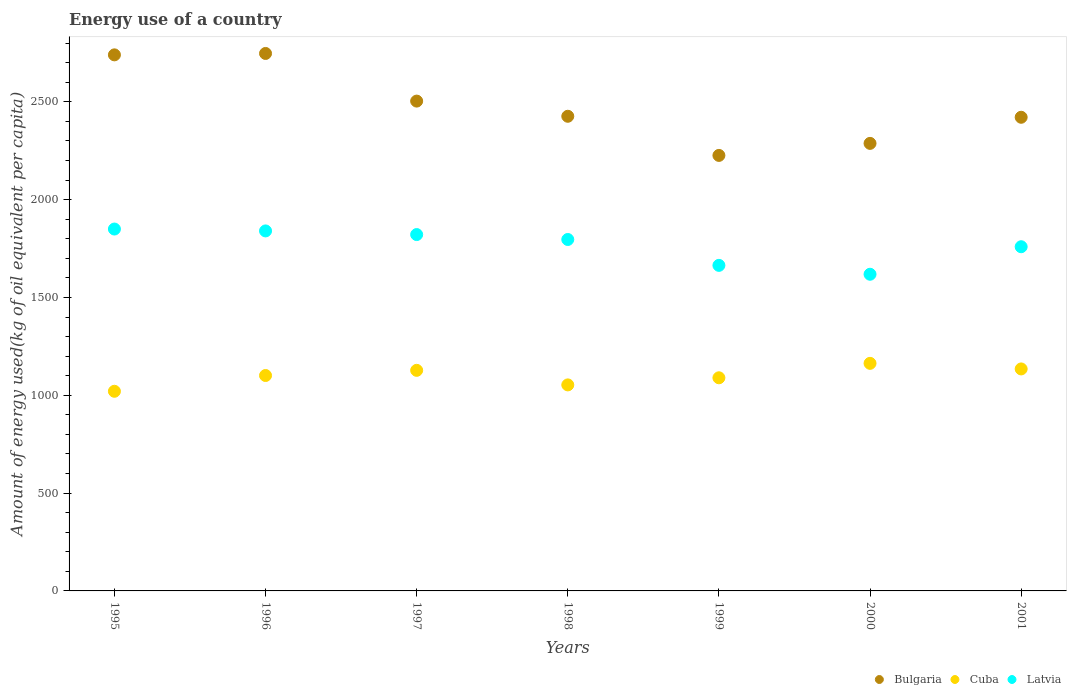How many different coloured dotlines are there?
Provide a succinct answer. 3. What is the amount of energy used in in Bulgaria in 1999?
Offer a terse response. 2225.87. Across all years, what is the maximum amount of energy used in in Latvia?
Provide a succinct answer. 1849.59. Across all years, what is the minimum amount of energy used in in Cuba?
Your answer should be very brief. 1020.37. In which year was the amount of energy used in in Latvia maximum?
Your answer should be very brief. 1995. What is the total amount of energy used in in Latvia in the graph?
Your answer should be very brief. 1.23e+04. What is the difference between the amount of energy used in in Bulgaria in 1999 and that in 2000?
Your answer should be very brief. -61.51. What is the difference between the amount of energy used in in Bulgaria in 1998 and the amount of energy used in in Latvia in 1997?
Your answer should be compact. 604.59. What is the average amount of energy used in in Cuba per year?
Offer a very short reply. 1098.4. In the year 1999, what is the difference between the amount of energy used in in Latvia and amount of energy used in in Bulgaria?
Your answer should be compact. -561.96. In how many years, is the amount of energy used in in Cuba greater than 2000 kg?
Make the answer very short. 0. What is the ratio of the amount of energy used in in Bulgaria in 1996 to that in 2000?
Your response must be concise. 1.2. Is the difference between the amount of energy used in in Latvia in 1997 and 1999 greater than the difference between the amount of energy used in in Bulgaria in 1997 and 1999?
Provide a short and direct response. No. What is the difference between the highest and the second highest amount of energy used in in Bulgaria?
Make the answer very short. 7.12. What is the difference between the highest and the lowest amount of energy used in in Latvia?
Your answer should be very brief. 231.13. Is the sum of the amount of energy used in in Bulgaria in 1998 and 2000 greater than the maximum amount of energy used in in Cuba across all years?
Your answer should be very brief. Yes. Is it the case that in every year, the sum of the amount of energy used in in Bulgaria and amount of energy used in in Latvia  is greater than the amount of energy used in in Cuba?
Make the answer very short. Yes. Is the amount of energy used in in Cuba strictly greater than the amount of energy used in in Latvia over the years?
Offer a terse response. No. Is the amount of energy used in in Bulgaria strictly less than the amount of energy used in in Latvia over the years?
Provide a short and direct response. No. How many years are there in the graph?
Your response must be concise. 7. How many legend labels are there?
Give a very brief answer. 3. What is the title of the graph?
Offer a terse response. Energy use of a country. What is the label or title of the Y-axis?
Your response must be concise. Amount of energy used(kg of oil equivalent per capita). What is the Amount of energy used(kg of oil equivalent per capita) of Bulgaria in 1995?
Keep it short and to the point. 2739.84. What is the Amount of energy used(kg of oil equivalent per capita) in Cuba in 1995?
Provide a succinct answer. 1020.37. What is the Amount of energy used(kg of oil equivalent per capita) in Latvia in 1995?
Provide a succinct answer. 1849.59. What is the Amount of energy used(kg of oil equivalent per capita) in Bulgaria in 1996?
Provide a succinct answer. 2746.96. What is the Amount of energy used(kg of oil equivalent per capita) of Cuba in 1996?
Ensure brevity in your answer.  1100.99. What is the Amount of energy used(kg of oil equivalent per capita) of Latvia in 1996?
Your response must be concise. 1839.98. What is the Amount of energy used(kg of oil equivalent per capita) in Bulgaria in 1997?
Provide a succinct answer. 2503.53. What is the Amount of energy used(kg of oil equivalent per capita) of Cuba in 1997?
Provide a short and direct response. 1127.4. What is the Amount of energy used(kg of oil equivalent per capita) of Latvia in 1997?
Keep it short and to the point. 1821.35. What is the Amount of energy used(kg of oil equivalent per capita) in Bulgaria in 1998?
Offer a very short reply. 2425.95. What is the Amount of energy used(kg of oil equivalent per capita) of Cuba in 1998?
Your answer should be very brief. 1053.01. What is the Amount of energy used(kg of oil equivalent per capita) in Latvia in 1998?
Your answer should be compact. 1796.18. What is the Amount of energy used(kg of oil equivalent per capita) of Bulgaria in 1999?
Your response must be concise. 2225.87. What is the Amount of energy used(kg of oil equivalent per capita) in Cuba in 1999?
Keep it short and to the point. 1089.34. What is the Amount of energy used(kg of oil equivalent per capita) in Latvia in 1999?
Give a very brief answer. 1663.92. What is the Amount of energy used(kg of oil equivalent per capita) of Bulgaria in 2000?
Ensure brevity in your answer.  2287.38. What is the Amount of energy used(kg of oil equivalent per capita) in Cuba in 2000?
Give a very brief answer. 1163.13. What is the Amount of energy used(kg of oil equivalent per capita) in Latvia in 2000?
Keep it short and to the point. 1618.46. What is the Amount of energy used(kg of oil equivalent per capita) of Bulgaria in 2001?
Make the answer very short. 2420.85. What is the Amount of energy used(kg of oil equivalent per capita) of Cuba in 2001?
Give a very brief answer. 1134.58. What is the Amount of energy used(kg of oil equivalent per capita) in Latvia in 2001?
Offer a very short reply. 1759.16. Across all years, what is the maximum Amount of energy used(kg of oil equivalent per capita) in Bulgaria?
Your answer should be very brief. 2746.96. Across all years, what is the maximum Amount of energy used(kg of oil equivalent per capita) in Cuba?
Provide a short and direct response. 1163.13. Across all years, what is the maximum Amount of energy used(kg of oil equivalent per capita) of Latvia?
Keep it short and to the point. 1849.59. Across all years, what is the minimum Amount of energy used(kg of oil equivalent per capita) of Bulgaria?
Keep it short and to the point. 2225.87. Across all years, what is the minimum Amount of energy used(kg of oil equivalent per capita) of Cuba?
Provide a short and direct response. 1020.37. Across all years, what is the minimum Amount of energy used(kg of oil equivalent per capita) in Latvia?
Offer a very short reply. 1618.46. What is the total Amount of energy used(kg of oil equivalent per capita) in Bulgaria in the graph?
Offer a terse response. 1.74e+04. What is the total Amount of energy used(kg of oil equivalent per capita) in Cuba in the graph?
Offer a terse response. 7688.82. What is the total Amount of energy used(kg of oil equivalent per capita) in Latvia in the graph?
Provide a short and direct response. 1.23e+04. What is the difference between the Amount of energy used(kg of oil equivalent per capita) in Bulgaria in 1995 and that in 1996?
Provide a succinct answer. -7.12. What is the difference between the Amount of energy used(kg of oil equivalent per capita) of Cuba in 1995 and that in 1996?
Provide a succinct answer. -80.61. What is the difference between the Amount of energy used(kg of oil equivalent per capita) in Latvia in 1995 and that in 1996?
Offer a very short reply. 9.6. What is the difference between the Amount of energy used(kg of oil equivalent per capita) of Bulgaria in 1995 and that in 1997?
Give a very brief answer. 236.32. What is the difference between the Amount of energy used(kg of oil equivalent per capita) in Cuba in 1995 and that in 1997?
Offer a very short reply. -107.03. What is the difference between the Amount of energy used(kg of oil equivalent per capita) in Latvia in 1995 and that in 1997?
Provide a short and direct response. 28.23. What is the difference between the Amount of energy used(kg of oil equivalent per capita) of Bulgaria in 1995 and that in 1998?
Ensure brevity in your answer.  313.9. What is the difference between the Amount of energy used(kg of oil equivalent per capita) of Cuba in 1995 and that in 1998?
Your answer should be very brief. -32.64. What is the difference between the Amount of energy used(kg of oil equivalent per capita) of Latvia in 1995 and that in 1998?
Your response must be concise. 53.4. What is the difference between the Amount of energy used(kg of oil equivalent per capita) of Bulgaria in 1995 and that in 1999?
Provide a succinct answer. 513.97. What is the difference between the Amount of energy used(kg of oil equivalent per capita) of Cuba in 1995 and that in 1999?
Provide a short and direct response. -68.97. What is the difference between the Amount of energy used(kg of oil equivalent per capita) of Latvia in 1995 and that in 1999?
Ensure brevity in your answer.  185.67. What is the difference between the Amount of energy used(kg of oil equivalent per capita) in Bulgaria in 1995 and that in 2000?
Give a very brief answer. 452.46. What is the difference between the Amount of energy used(kg of oil equivalent per capita) in Cuba in 1995 and that in 2000?
Give a very brief answer. -142.76. What is the difference between the Amount of energy used(kg of oil equivalent per capita) of Latvia in 1995 and that in 2000?
Your answer should be compact. 231.13. What is the difference between the Amount of energy used(kg of oil equivalent per capita) in Bulgaria in 1995 and that in 2001?
Offer a very short reply. 318.99. What is the difference between the Amount of energy used(kg of oil equivalent per capita) of Cuba in 1995 and that in 2001?
Your response must be concise. -114.21. What is the difference between the Amount of energy used(kg of oil equivalent per capita) in Latvia in 1995 and that in 2001?
Provide a short and direct response. 90.42. What is the difference between the Amount of energy used(kg of oil equivalent per capita) of Bulgaria in 1996 and that in 1997?
Provide a short and direct response. 243.43. What is the difference between the Amount of energy used(kg of oil equivalent per capita) in Cuba in 1996 and that in 1997?
Your answer should be compact. -26.41. What is the difference between the Amount of energy used(kg of oil equivalent per capita) in Latvia in 1996 and that in 1997?
Give a very brief answer. 18.63. What is the difference between the Amount of energy used(kg of oil equivalent per capita) in Bulgaria in 1996 and that in 1998?
Keep it short and to the point. 321.01. What is the difference between the Amount of energy used(kg of oil equivalent per capita) in Cuba in 1996 and that in 1998?
Give a very brief answer. 47.97. What is the difference between the Amount of energy used(kg of oil equivalent per capita) of Latvia in 1996 and that in 1998?
Offer a terse response. 43.8. What is the difference between the Amount of energy used(kg of oil equivalent per capita) of Bulgaria in 1996 and that in 1999?
Your response must be concise. 521.09. What is the difference between the Amount of energy used(kg of oil equivalent per capita) in Cuba in 1996 and that in 1999?
Make the answer very short. 11.64. What is the difference between the Amount of energy used(kg of oil equivalent per capita) of Latvia in 1996 and that in 1999?
Your answer should be compact. 176.07. What is the difference between the Amount of energy used(kg of oil equivalent per capita) of Bulgaria in 1996 and that in 2000?
Provide a succinct answer. 459.58. What is the difference between the Amount of energy used(kg of oil equivalent per capita) of Cuba in 1996 and that in 2000?
Your response must be concise. -62.15. What is the difference between the Amount of energy used(kg of oil equivalent per capita) in Latvia in 1996 and that in 2000?
Your response must be concise. 221.52. What is the difference between the Amount of energy used(kg of oil equivalent per capita) of Bulgaria in 1996 and that in 2001?
Give a very brief answer. 326.11. What is the difference between the Amount of energy used(kg of oil equivalent per capita) in Cuba in 1996 and that in 2001?
Give a very brief answer. -33.6. What is the difference between the Amount of energy used(kg of oil equivalent per capita) in Latvia in 1996 and that in 2001?
Your answer should be very brief. 80.82. What is the difference between the Amount of energy used(kg of oil equivalent per capita) in Bulgaria in 1997 and that in 1998?
Make the answer very short. 77.58. What is the difference between the Amount of energy used(kg of oil equivalent per capita) of Cuba in 1997 and that in 1998?
Provide a short and direct response. 74.38. What is the difference between the Amount of energy used(kg of oil equivalent per capita) of Latvia in 1997 and that in 1998?
Your answer should be compact. 25.17. What is the difference between the Amount of energy used(kg of oil equivalent per capita) in Bulgaria in 1997 and that in 1999?
Keep it short and to the point. 277.65. What is the difference between the Amount of energy used(kg of oil equivalent per capita) in Cuba in 1997 and that in 1999?
Your answer should be compact. 38.05. What is the difference between the Amount of energy used(kg of oil equivalent per capita) in Latvia in 1997 and that in 1999?
Give a very brief answer. 157.44. What is the difference between the Amount of energy used(kg of oil equivalent per capita) of Bulgaria in 1997 and that in 2000?
Give a very brief answer. 216.14. What is the difference between the Amount of energy used(kg of oil equivalent per capita) of Cuba in 1997 and that in 2000?
Provide a succinct answer. -35.73. What is the difference between the Amount of energy used(kg of oil equivalent per capita) in Latvia in 1997 and that in 2000?
Give a very brief answer. 202.89. What is the difference between the Amount of energy used(kg of oil equivalent per capita) in Bulgaria in 1997 and that in 2001?
Offer a terse response. 82.67. What is the difference between the Amount of energy used(kg of oil equivalent per capita) of Cuba in 1997 and that in 2001?
Give a very brief answer. -7.18. What is the difference between the Amount of energy used(kg of oil equivalent per capita) of Latvia in 1997 and that in 2001?
Your answer should be very brief. 62.19. What is the difference between the Amount of energy used(kg of oil equivalent per capita) of Bulgaria in 1998 and that in 1999?
Your answer should be compact. 200.07. What is the difference between the Amount of energy used(kg of oil equivalent per capita) in Cuba in 1998 and that in 1999?
Give a very brief answer. -36.33. What is the difference between the Amount of energy used(kg of oil equivalent per capita) in Latvia in 1998 and that in 1999?
Offer a very short reply. 132.27. What is the difference between the Amount of energy used(kg of oil equivalent per capita) of Bulgaria in 1998 and that in 2000?
Offer a very short reply. 138.56. What is the difference between the Amount of energy used(kg of oil equivalent per capita) of Cuba in 1998 and that in 2000?
Provide a short and direct response. -110.12. What is the difference between the Amount of energy used(kg of oil equivalent per capita) in Latvia in 1998 and that in 2000?
Provide a succinct answer. 177.72. What is the difference between the Amount of energy used(kg of oil equivalent per capita) of Bulgaria in 1998 and that in 2001?
Provide a short and direct response. 5.09. What is the difference between the Amount of energy used(kg of oil equivalent per capita) in Cuba in 1998 and that in 2001?
Make the answer very short. -81.57. What is the difference between the Amount of energy used(kg of oil equivalent per capita) in Latvia in 1998 and that in 2001?
Offer a terse response. 37.02. What is the difference between the Amount of energy used(kg of oil equivalent per capita) in Bulgaria in 1999 and that in 2000?
Make the answer very short. -61.51. What is the difference between the Amount of energy used(kg of oil equivalent per capita) of Cuba in 1999 and that in 2000?
Keep it short and to the point. -73.79. What is the difference between the Amount of energy used(kg of oil equivalent per capita) of Latvia in 1999 and that in 2000?
Ensure brevity in your answer.  45.45. What is the difference between the Amount of energy used(kg of oil equivalent per capita) in Bulgaria in 1999 and that in 2001?
Ensure brevity in your answer.  -194.98. What is the difference between the Amount of energy used(kg of oil equivalent per capita) of Cuba in 1999 and that in 2001?
Offer a very short reply. -45.24. What is the difference between the Amount of energy used(kg of oil equivalent per capita) in Latvia in 1999 and that in 2001?
Your response must be concise. -95.25. What is the difference between the Amount of energy used(kg of oil equivalent per capita) in Bulgaria in 2000 and that in 2001?
Make the answer very short. -133.47. What is the difference between the Amount of energy used(kg of oil equivalent per capita) of Cuba in 2000 and that in 2001?
Give a very brief answer. 28.55. What is the difference between the Amount of energy used(kg of oil equivalent per capita) of Latvia in 2000 and that in 2001?
Keep it short and to the point. -140.7. What is the difference between the Amount of energy used(kg of oil equivalent per capita) of Bulgaria in 1995 and the Amount of energy used(kg of oil equivalent per capita) of Cuba in 1996?
Your answer should be compact. 1638.86. What is the difference between the Amount of energy used(kg of oil equivalent per capita) of Bulgaria in 1995 and the Amount of energy used(kg of oil equivalent per capita) of Latvia in 1996?
Keep it short and to the point. 899.86. What is the difference between the Amount of energy used(kg of oil equivalent per capita) of Cuba in 1995 and the Amount of energy used(kg of oil equivalent per capita) of Latvia in 1996?
Your answer should be very brief. -819.61. What is the difference between the Amount of energy used(kg of oil equivalent per capita) of Bulgaria in 1995 and the Amount of energy used(kg of oil equivalent per capita) of Cuba in 1997?
Keep it short and to the point. 1612.45. What is the difference between the Amount of energy used(kg of oil equivalent per capita) of Bulgaria in 1995 and the Amount of energy used(kg of oil equivalent per capita) of Latvia in 1997?
Provide a short and direct response. 918.49. What is the difference between the Amount of energy used(kg of oil equivalent per capita) of Cuba in 1995 and the Amount of energy used(kg of oil equivalent per capita) of Latvia in 1997?
Your answer should be very brief. -800.98. What is the difference between the Amount of energy used(kg of oil equivalent per capita) in Bulgaria in 1995 and the Amount of energy used(kg of oil equivalent per capita) in Cuba in 1998?
Give a very brief answer. 1686.83. What is the difference between the Amount of energy used(kg of oil equivalent per capita) of Bulgaria in 1995 and the Amount of energy used(kg of oil equivalent per capita) of Latvia in 1998?
Your answer should be compact. 943.66. What is the difference between the Amount of energy used(kg of oil equivalent per capita) of Cuba in 1995 and the Amount of energy used(kg of oil equivalent per capita) of Latvia in 1998?
Your answer should be compact. -775.81. What is the difference between the Amount of energy used(kg of oil equivalent per capita) of Bulgaria in 1995 and the Amount of energy used(kg of oil equivalent per capita) of Cuba in 1999?
Give a very brief answer. 1650.5. What is the difference between the Amount of energy used(kg of oil equivalent per capita) of Bulgaria in 1995 and the Amount of energy used(kg of oil equivalent per capita) of Latvia in 1999?
Offer a terse response. 1075.93. What is the difference between the Amount of energy used(kg of oil equivalent per capita) in Cuba in 1995 and the Amount of energy used(kg of oil equivalent per capita) in Latvia in 1999?
Your answer should be compact. -643.54. What is the difference between the Amount of energy used(kg of oil equivalent per capita) in Bulgaria in 1995 and the Amount of energy used(kg of oil equivalent per capita) in Cuba in 2000?
Provide a short and direct response. 1576.71. What is the difference between the Amount of energy used(kg of oil equivalent per capita) in Bulgaria in 1995 and the Amount of energy used(kg of oil equivalent per capita) in Latvia in 2000?
Your answer should be very brief. 1121.38. What is the difference between the Amount of energy used(kg of oil equivalent per capita) of Cuba in 1995 and the Amount of energy used(kg of oil equivalent per capita) of Latvia in 2000?
Keep it short and to the point. -598.09. What is the difference between the Amount of energy used(kg of oil equivalent per capita) in Bulgaria in 1995 and the Amount of energy used(kg of oil equivalent per capita) in Cuba in 2001?
Your answer should be compact. 1605.26. What is the difference between the Amount of energy used(kg of oil equivalent per capita) in Bulgaria in 1995 and the Amount of energy used(kg of oil equivalent per capita) in Latvia in 2001?
Offer a very short reply. 980.68. What is the difference between the Amount of energy used(kg of oil equivalent per capita) in Cuba in 1995 and the Amount of energy used(kg of oil equivalent per capita) in Latvia in 2001?
Make the answer very short. -738.79. What is the difference between the Amount of energy used(kg of oil equivalent per capita) in Bulgaria in 1996 and the Amount of energy used(kg of oil equivalent per capita) in Cuba in 1997?
Your response must be concise. 1619.56. What is the difference between the Amount of energy used(kg of oil equivalent per capita) in Bulgaria in 1996 and the Amount of energy used(kg of oil equivalent per capita) in Latvia in 1997?
Ensure brevity in your answer.  925.61. What is the difference between the Amount of energy used(kg of oil equivalent per capita) in Cuba in 1996 and the Amount of energy used(kg of oil equivalent per capita) in Latvia in 1997?
Offer a terse response. -720.37. What is the difference between the Amount of energy used(kg of oil equivalent per capita) in Bulgaria in 1996 and the Amount of energy used(kg of oil equivalent per capita) in Cuba in 1998?
Provide a succinct answer. 1693.95. What is the difference between the Amount of energy used(kg of oil equivalent per capita) in Bulgaria in 1996 and the Amount of energy used(kg of oil equivalent per capita) in Latvia in 1998?
Give a very brief answer. 950.78. What is the difference between the Amount of energy used(kg of oil equivalent per capita) of Cuba in 1996 and the Amount of energy used(kg of oil equivalent per capita) of Latvia in 1998?
Your response must be concise. -695.2. What is the difference between the Amount of energy used(kg of oil equivalent per capita) in Bulgaria in 1996 and the Amount of energy used(kg of oil equivalent per capita) in Cuba in 1999?
Ensure brevity in your answer.  1657.62. What is the difference between the Amount of energy used(kg of oil equivalent per capita) of Bulgaria in 1996 and the Amount of energy used(kg of oil equivalent per capita) of Latvia in 1999?
Provide a short and direct response. 1083.05. What is the difference between the Amount of energy used(kg of oil equivalent per capita) of Cuba in 1996 and the Amount of energy used(kg of oil equivalent per capita) of Latvia in 1999?
Offer a terse response. -562.93. What is the difference between the Amount of energy used(kg of oil equivalent per capita) in Bulgaria in 1996 and the Amount of energy used(kg of oil equivalent per capita) in Cuba in 2000?
Give a very brief answer. 1583.83. What is the difference between the Amount of energy used(kg of oil equivalent per capita) in Bulgaria in 1996 and the Amount of energy used(kg of oil equivalent per capita) in Latvia in 2000?
Provide a succinct answer. 1128.5. What is the difference between the Amount of energy used(kg of oil equivalent per capita) of Cuba in 1996 and the Amount of energy used(kg of oil equivalent per capita) of Latvia in 2000?
Give a very brief answer. -517.47. What is the difference between the Amount of energy used(kg of oil equivalent per capita) in Bulgaria in 1996 and the Amount of energy used(kg of oil equivalent per capita) in Cuba in 2001?
Keep it short and to the point. 1612.38. What is the difference between the Amount of energy used(kg of oil equivalent per capita) in Bulgaria in 1996 and the Amount of energy used(kg of oil equivalent per capita) in Latvia in 2001?
Your answer should be very brief. 987.8. What is the difference between the Amount of energy used(kg of oil equivalent per capita) of Cuba in 1996 and the Amount of energy used(kg of oil equivalent per capita) of Latvia in 2001?
Your answer should be compact. -658.18. What is the difference between the Amount of energy used(kg of oil equivalent per capita) in Bulgaria in 1997 and the Amount of energy used(kg of oil equivalent per capita) in Cuba in 1998?
Make the answer very short. 1450.51. What is the difference between the Amount of energy used(kg of oil equivalent per capita) in Bulgaria in 1997 and the Amount of energy used(kg of oil equivalent per capita) in Latvia in 1998?
Your answer should be very brief. 707.35. What is the difference between the Amount of energy used(kg of oil equivalent per capita) of Cuba in 1997 and the Amount of energy used(kg of oil equivalent per capita) of Latvia in 1998?
Offer a terse response. -668.78. What is the difference between the Amount of energy used(kg of oil equivalent per capita) of Bulgaria in 1997 and the Amount of energy used(kg of oil equivalent per capita) of Cuba in 1999?
Offer a very short reply. 1414.18. What is the difference between the Amount of energy used(kg of oil equivalent per capita) of Bulgaria in 1997 and the Amount of energy used(kg of oil equivalent per capita) of Latvia in 1999?
Provide a succinct answer. 839.61. What is the difference between the Amount of energy used(kg of oil equivalent per capita) in Cuba in 1997 and the Amount of energy used(kg of oil equivalent per capita) in Latvia in 1999?
Give a very brief answer. -536.52. What is the difference between the Amount of energy used(kg of oil equivalent per capita) in Bulgaria in 1997 and the Amount of energy used(kg of oil equivalent per capita) in Cuba in 2000?
Provide a short and direct response. 1340.4. What is the difference between the Amount of energy used(kg of oil equivalent per capita) of Bulgaria in 1997 and the Amount of energy used(kg of oil equivalent per capita) of Latvia in 2000?
Ensure brevity in your answer.  885.07. What is the difference between the Amount of energy used(kg of oil equivalent per capita) in Cuba in 1997 and the Amount of energy used(kg of oil equivalent per capita) in Latvia in 2000?
Your answer should be compact. -491.06. What is the difference between the Amount of energy used(kg of oil equivalent per capita) of Bulgaria in 1997 and the Amount of energy used(kg of oil equivalent per capita) of Cuba in 2001?
Your answer should be very brief. 1368.95. What is the difference between the Amount of energy used(kg of oil equivalent per capita) of Bulgaria in 1997 and the Amount of energy used(kg of oil equivalent per capita) of Latvia in 2001?
Keep it short and to the point. 744.37. What is the difference between the Amount of energy used(kg of oil equivalent per capita) of Cuba in 1997 and the Amount of energy used(kg of oil equivalent per capita) of Latvia in 2001?
Provide a succinct answer. -631.76. What is the difference between the Amount of energy used(kg of oil equivalent per capita) in Bulgaria in 1998 and the Amount of energy used(kg of oil equivalent per capita) in Cuba in 1999?
Provide a short and direct response. 1336.6. What is the difference between the Amount of energy used(kg of oil equivalent per capita) of Bulgaria in 1998 and the Amount of energy used(kg of oil equivalent per capita) of Latvia in 1999?
Make the answer very short. 762.03. What is the difference between the Amount of energy used(kg of oil equivalent per capita) of Cuba in 1998 and the Amount of energy used(kg of oil equivalent per capita) of Latvia in 1999?
Your answer should be very brief. -610.9. What is the difference between the Amount of energy used(kg of oil equivalent per capita) of Bulgaria in 1998 and the Amount of energy used(kg of oil equivalent per capita) of Cuba in 2000?
Offer a very short reply. 1262.82. What is the difference between the Amount of energy used(kg of oil equivalent per capita) of Bulgaria in 1998 and the Amount of energy used(kg of oil equivalent per capita) of Latvia in 2000?
Offer a very short reply. 807.49. What is the difference between the Amount of energy used(kg of oil equivalent per capita) in Cuba in 1998 and the Amount of energy used(kg of oil equivalent per capita) in Latvia in 2000?
Make the answer very short. -565.45. What is the difference between the Amount of energy used(kg of oil equivalent per capita) in Bulgaria in 1998 and the Amount of energy used(kg of oil equivalent per capita) in Cuba in 2001?
Keep it short and to the point. 1291.37. What is the difference between the Amount of energy used(kg of oil equivalent per capita) in Bulgaria in 1998 and the Amount of energy used(kg of oil equivalent per capita) in Latvia in 2001?
Keep it short and to the point. 666.79. What is the difference between the Amount of energy used(kg of oil equivalent per capita) in Cuba in 1998 and the Amount of energy used(kg of oil equivalent per capita) in Latvia in 2001?
Offer a very short reply. -706.15. What is the difference between the Amount of energy used(kg of oil equivalent per capita) of Bulgaria in 1999 and the Amount of energy used(kg of oil equivalent per capita) of Cuba in 2000?
Make the answer very short. 1062.74. What is the difference between the Amount of energy used(kg of oil equivalent per capita) in Bulgaria in 1999 and the Amount of energy used(kg of oil equivalent per capita) in Latvia in 2000?
Ensure brevity in your answer.  607.41. What is the difference between the Amount of energy used(kg of oil equivalent per capita) in Cuba in 1999 and the Amount of energy used(kg of oil equivalent per capita) in Latvia in 2000?
Provide a succinct answer. -529.12. What is the difference between the Amount of energy used(kg of oil equivalent per capita) of Bulgaria in 1999 and the Amount of energy used(kg of oil equivalent per capita) of Cuba in 2001?
Your answer should be compact. 1091.29. What is the difference between the Amount of energy used(kg of oil equivalent per capita) of Bulgaria in 1999 and the Amount of energy used(kg of oil equivalent per capita) of Latvia in 2001?
Ensure brevity in your answer.  466.71. What is the difference between the Amount of energy used(kg of oil equivalent per capita) in Cuba in 1999 and the Amount of energy used(kg of oil equivalent per capita) in Latvia in 2001?
Offer a terse response. -669.82. What is the difference between the Amount of energy used(kg of oil equivalent per capita) of Bulgaria in 2000 and the Amount of energy used(kg of oil equivalent per capita) of Cuba in 2001?
Ensure brevity in your answer.  1152.8. What is the difference between the Amount of energy used(kg of oil equivalent per capita) in Bulgaria in 2000 and the Amount of energy used(kg of oil equivalent per capita) in Latvia in 2001?
Your response must be concise. 528.22. What is the difference between the Amount of energy used(kg of oil equivalent per capita) of Cuba in 2000 and the Amount of energy used(kg of oil equivalent per capita) of Latvia in 2001?
Give a very brief answer. -596.03. What is the average Amount of energy used(kg of oil equivalent per capita) of Bulgaria per year?
Provide a short and direct response. 2478.63. What is the average Amount of energy used(kg of oil equivalent per capita) in Cuba per year?
Offer a terse response. 1098.4. What is the average Amount of energy used(kg of oil equivalent per capita) in Latvia per year?
Your response must be concise. 1764.09. In the year 1995, what is the difference between the Amount of energy used(kg of oil equivalent per capita) of Bulgaria and Amount of energy used(kg of oil equivalent per capita) of Cuba?
Your response must be concise. 1719.47. In the year 1995, what is the difference between the Amount of energy used(kg of oil equivalent per capita) in Bulgaria and Amount of energy used(kg of oil equivalent per capita) in Latvia?
Make the answer very short. 890.26. In the year 1995, what is the difference between the Amount of energy used(kg of oil equivalent per capita) of Cuba and Amount of energy used(kg of oil equivalent per capita) of Latvia?
Keep it short and to the point. -829.21. In the year 1996, what is the difference between the Amount of energy used(kg of oil equivalent per capita) in Bulgaria and Amount of energy used(kg of oil equivalent per capita) in Cuba?
Provide a succinct answer. 1645.97. In the year 1996, what is the difference between the Amount of energy used(kg of oil equivalent per capita) of Bulgaria and Amount of energy used(kg of oil equivalent per capita) of Latvia?
Ensure brevity in your answer.  906.98. In the year 1996, what is the difference between the Amount of energy used(kg of oil equivalent per capita) of Cuba and Amount of energy used(kg of oil equivalent per capita) of Latvia?
Offer a very short reply. -739. In the year 1997, what is the difference between the Amount of energy used(kg of oil equivalent per capita) of Bulgaria and Amount of energy used(kg of oil equivalent per capita) of Cuba?
Offer a terse response. 1376.13. In the year 1997, what is the difference between the Amount of energy used(kg of oil equivalent per capita) of Bulgaria and Amount of energy used(kg of oil equivalent per capita) of Latvia?
Give a very brief answer. 682.17. In the year 1997, what is the difference between the Amount of energy used(kg of oil equivalent per capita) of Cuba and Amount of energy used(kg of oil equivalent per capita) of Latvia?
Ensure brevity in your answer.  -693.96. In the year 1998, what is the difference between the Amount of energy used(kg of oil equivalent per capita) in Bulgaria and Amount of energy used(kg of oil equivalent per capita) in Cuba?
Your answer should be very brief. 1372.93. In the year 1998, what is the difference between the Amount of energy used(kg of oil equivalent per capita) of Bulgaria and Amount of energy used(kg of oil equivalent per capita) of Latvia?
Offer a very short reply. 629.77. In the year 1998, what is the difference between the Amount of energy used(kg of oil equivalent per capita) of Cuba and Amount of energy used(kg of oil equivalent per capita) of Latvia?
Keep it short and to the point. -743.17. In the year 1999, what is the difference between the Amount of energy used(kg of oil equivalent per capita) of Bulgaria and Amount of energy used(kg of oil equivalent per capita) of Cuba?
Keep it short and to the point. 1136.53. In the year 1999, what is the difference between the Amount of energy used(kg of oil equivalent per capita) of Bulgaria and Amount of energy used(kg of oil equivalent per capita) of Latvia?
Ensure brevity in your answer.  561.96. In the year 1999, what is the difference between the Amount of energy used(kg of oil equivalent per capita) in Cuba and Amount of energy used(kg of oil equivalent per capita) in Latvia?
Provide a short and direct response. -574.57. In the year 2000, what is the difference between the Amount of energy used(kg of oil equivalent per capita) of Bulgaria and Amount of energy used(kg of oil equivalent per capita) of Cuba?
Your answer should be very brief. 1124.25. In the year 2000, what is the difference between the Amount of energy used(kg of oil equivalent per capita) of Bulgaria and Amount of energy used(kg of oil equivalent per capita) of Latvia?
Your answer should be compact. 668.92. In the year 2000, what is the difference between the Amount of energy used(kg of oil equivalent per capita) of Cuba and Amount of energy used(kg of oil equivalent per capita) of Latvia?
Keep it short and to the point. -455.33. In the year 2001, what is the difference between the Amount of energy used(kg of oil equivalent per capita) of Bulgaria and Amount of energy used(kg of oil equivalent per capita) of Cuba?
Offer a terse response. 1286.27. In the year 2001, what is the difference between the Amount of energy used(kg of oil equivalent per capita) in Bulgaria and Amount of energy used(kg of oil equivalent per capita) in Latvia?
Give a very brief answer. 661.69. In the year 2001, what is the difference between the Amount of energy used(kg of oil equivalent per capita) of Cuba and Amount of energy used(kg of oil equivalent per capita) of Latvia?
Make the answer very short. -624.58. What is the ratio of the Amount of energy used(kg of oil equivalent per capita) in Cuba in 1995 to that in 1996?
Offer a terse response. 0.93. What is the ratio of the Amount of energy used(kg of oil equivalent per capita) in Latvia in 1995 to that in 1996?
Ensure brevity in your answer.  1.01. What is the ratio of the Amount of energy used(kg of oil equivalent per capita) of Bulgaria in 1995 to that in 1997?
Your answer should be compact. 1.09. What is the ratio of the Amount of energy used(kg of oil equivalent per capita) in Cuba in 1995 to that in 1997?
Offer a very short reply. 0.91. What is the ratio of the Amount of energy used(kg of oil equivalent per capita) in Latvia in 1995 to that in 1997?
Make the answer very short. 1.02. What is the ratio of the Amount of energy used(kg of oil equivalent per capita) of Bulgaria in 1995 to that in 1998?
Your response must be concise. 1.13. What is the ratio of the Amount of energy used(kg of oil equivalent per capita) of Latvia in 1995 to that in 1998?
Provide a succinct answer. 1.03. What is the ratio of the Amount of energy used(kg of oil equivalent per capita) in Bulgaria in 1995 to that in 1999?
Make the answer very short. 1.23. What is the ratio of the Amount of energy used(kg of oil equivalent per capita) in Cuba in 1995 to that in 1999?
Give a very brief answer. 0.94. What is the ratio of the Amount of energy used(kg of oil equivalent per capita) of Latvia in 1995 to that in 1999?
Offer a very short reply. 1.11. What is the ratio of the Amount of energy used(kg of oil equivalent per capita) of Bulgaria in 1995 to that in 2000?
Give a very brief answer. 1.2. What is the ratio of the Amount of energy used(kg of oil equivalent per capita) in Cuba in 1995 to that in 2000?
Offer a very short reply. 0.88. What is the ratio of the Amount of energy used(kg of oil equivalent per capita) of Latvia in 1995 to that in 2000?
Offer a very short reply. 1.14. What is the ratio of the Amount of energy used(kg of oil equivalent per capita) in Bulgaria in 1995 to that in 2001?
Make the answer very short. 1.13. What is the ratio of the Amount of energy used(kg of oil equivalent per capita) in Cuba in 1995 to that in 2001?
Your answer should be very brief. 0.9. What is the ratio of the Amount of energy used(kg of oil equivalent per capita) of Latvia in 1995 to that in 2001?
Your response must be concise. 1.05. What is the ratio of the Amount of energy used(kg of oil equivalent per capita) of Bulgaria in 1996 to that in 1997?
Ensure brevity in your answer.  1.1. What is the ratio of the Amount of energy used(kg of oil equivalent per capita) of Cuba in 1996 to that in 1997?
Your answer should be very brief. 0.98. What is the ratio of the Amount of energy used(kg of oil equivalent per capita) of Latvia in 1996 to that in 1997?
Provide a succinct answer. 1.01. What is the ratio of the Amount of energy used(kg of oil equivalent per capita) in Bulgaria in 1996 to that in 1998?
Keep it short and to the point. 1.13. What is the ratio of the Amount of energy used(kg of oil equivalent per capita) in Cuba in 1996 to that in 1998?
Your answer should be very brief. 1.05. What is the ratio of the Amount of energy used(kg of oil equivalent per capita) of Latvia in 1996 to that in 1998?
Ensure brevity in your answer.  1.02. What is the ratio of the Amount of energy used(kg of oil equivalent per capita) in Bulgaria in 1996 to that in 1999?
Offer a terse response. 1.23. What is the ratio of the Amount of energy used(kg of oil equivalent per capita) of Cuba in 1996 to that in 1999?
Provide a short and direct response. 1.01. What is the ratio of the Amount of energy used(kg of oil equivalent per capita) in Latvia in 1996 to that in 1999?
Keep it short and to the point. 1.11. What is the ratio of the Amount of energy used(kg of oil equivalent per capita) in Bulgaria in 1996 to that in 2000?
Your answer should be very brief. 1.2. What is the ratio of the Amount of energy used(kg of oil equivalent per capita) in Cuba in 1996 to that in 2000?
Your answer should be very brief. 0.95. What is the ratio of the Amount of energy used(kg of oil equivalent per capita) in Latvia in 1996 to that in 2000?
Offer a terse response. 1.14. What is the ratio of the Amount of energy used(kg of oil equivalent per capita) of Bulgaria in 1996 to that in 2001?
Make the answer very short. 1.13. What is the ratio of the Amount of energy used(kg of oil equivalent per capita) in Cuba in 1996 to that in 2001?
Ensure brevity in your answer.  0.97. What is the ratio of the Amount of energy used(kg of oil equivalent per capita) of Latvia in 1996 to that in 2001?
Offer a very short reply. 1.05. What is the ratio of the Amount of energy used(kg of oil equivalent per capita) of Bulgaria in 1997 to that in 1998?
Offer a terse response. 1.03. What is the ratio of the Amount of energy used(kg of oil equivalent per capita) in Cuba in 1997 to that in 1998?
Give a very brief answer. 1.07. What is the ratio of the Amount of energy used(kg of oil equivalent per capita) in Latvia in 1997 to that in 1998?
Provide a succinct answer. 1.01. What is the ratio of the Amount of energy used(kg of oil equivalent per capita) in Bulgaria in 1997 to that in 1999?
Keep it short and to the point. 1.12. What is the ratio of the Amount of energy used(kg of oil equivalent per capita) of Cuba in 1997 to that in 1999?
Ensure brevity in your answer.  1.03. What is the ratio of the Amount of energy used(kg of oil equivalent per capita) of Latvia in 1997 to that in 1999?
Provide a succinct answer. 1.09. What is the ratio of the Amount of energy used(kg of oil equivalent per capita) in Bulgaria in 1997 to that in 2000?
Offer a very short reply. 1.09. What is the ratio of the Amount of energy used(kg of oil equivalent per capita) of Cuba in 1997 to that in 2000?
Provide a short and direct response. 0.97. What is the ratio of the Amount of energy used(kg of oil equivalent per capita) in Latvia in 1997 to that in 2000?
Provide a succinct answer. 1.13. What is the ratio of the Amount of energy used(kg of oil equivalent per capita) in Bulgaria in 1997 to that in 2001?
Your response must be concise. 1.03. What is the ratio of the Amount of energy used(kg of oil equivalent per capita) of Latvia in 1997 to that in 2001?
Give a very brief answer. 1.04. What is the ratio of the Amount of energy used(kg of oil equivalent per capita) in Bulgaria in 1998 to that in 1999?
Ensure brevity in your answer.  1.09. What is the ratio of the Amount of energy used(kg of oil equivalent per capita) in Cuba in 1998 to that in 1999?
Your response must be concise. 0.97. What is the ratio of the Amount of energy used(kg of oil equivalent per capita) of Latvia in 1998 to that in 1999?
Keep it short and to the point. 1.08. What is the ratio of the Amount of energy used(kg of oil equivalent per capita) in Bulgaria in 1998 to that in 2000?
Your answer should be very brief. 1.06. What is the ratio of the Amount of energy used(kg of oil equivalent per capita) in Cuba in 1998 to that in 2000?
Ensure brevity in your answer.  0.91. What is the ratio of the Amount of energy used(kg of oil equivalent per capita) in Latvia in 1998 to that in 2000?
Ensure brevity in your answer.  1.11. What is the ratio of the Amount of energy used(kg of oil equivalent per capita) of Cuba in 1998 to that in 2001?
Provide a short and direct response. 0.93. What is the ratio of the Amount of energy used(kg of oil equivalent per capita) in Bulgaria in 1999 to that in 2000?
Keep it short and to the point. 0.97. What is the ratio of the Amount of energy used(kg of oil equivalent per capita) in Cuba in 1999 to that in 2000?
Provide a short and direct response. 0.94. What is the ratio of the Amount of energy used(kg of oil equivalent per capita) of Latvia in 1999 to that in 2000?
Provide a short and direct response. 1.03. What is the ratio of the Amount of energy used(kg of oil equivalent per capita) in Bulgaria in 1999 to that in 2001?
Give a very brief answer. 0.92. What is the ratio of the Amount of energy used(kg of oil equivalent per capita) in Cuba in 1999 to that in 2001?
Provide a succinct answer. 0.96. What is the ratio of the Amount of energy used(kg of oil equivalent per capita) in Latvia in 1999 to that in 2001?
Your answer should be very brief. 0.95. What is the ratio of the Amount of energy used(kg of oil equivalent per capita) in Bulgaria in 2000 to that in 2001?
Ensure brevity in your answer.  0.94. What is the ratio of the Amount of energy used(kg of oil equivalent per capita) in Cuba in 2000 to that in 2001?
Your answer should be compact. 1.03. What is the difference between the highest and the second highest Amount of energy used(kg of oil equivalent per capita) in Bulgaria?
Provide a short and direct response. 7.12. What is the difference between the highest and the second highest Amount of energy used(kg of oil equivalent per capita) in Cuba?
Offer a very short reply. 28.55. What is the difference between the highest and the second highest Amount of energy used(kg of oil equivalent per capita) of Latvia?
Ensure brevity in your answer.  9.6. What is the difference between the highest and the lowest Amount of energy used(kg of oil equivalent per capita) in Bulgaria?
Your answer should be compact. 521.09. What is the difference between the highest and the lowest Amount of energy used(kg of oil equivalent per capita) of Cuba?
Offer a very short reply. 142.76. What is the difference between the highest and the lowest Amount of energy used(kg of oil equivalent per capita) of Latvia?
Keep it short and to the point. 231.13. 